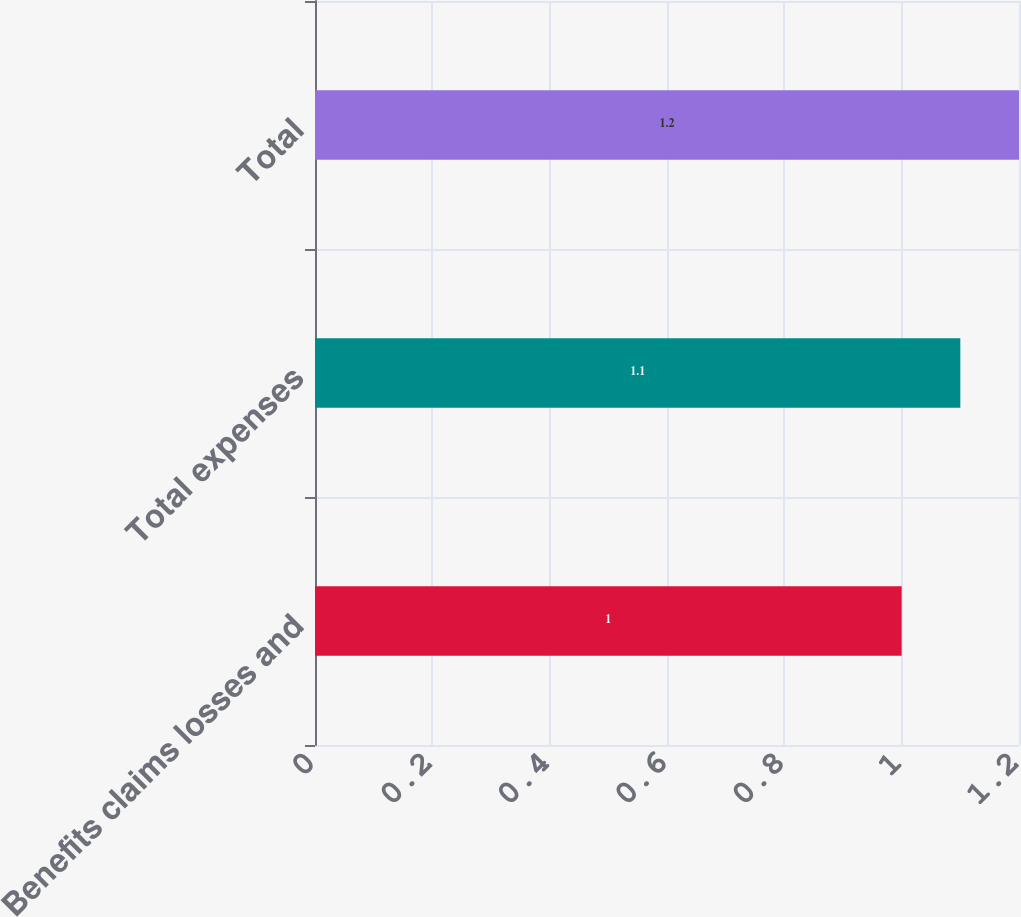Convert chart to OTSL. <chart><loc_0><loc_0><loc_500><loc_500><bar_chart><fcel>Benefits claims losses and<fcel>Total expenses<fcel>Total<nl><fcel>1<fcel>1.1<fcel>1.2<nl></chart> 